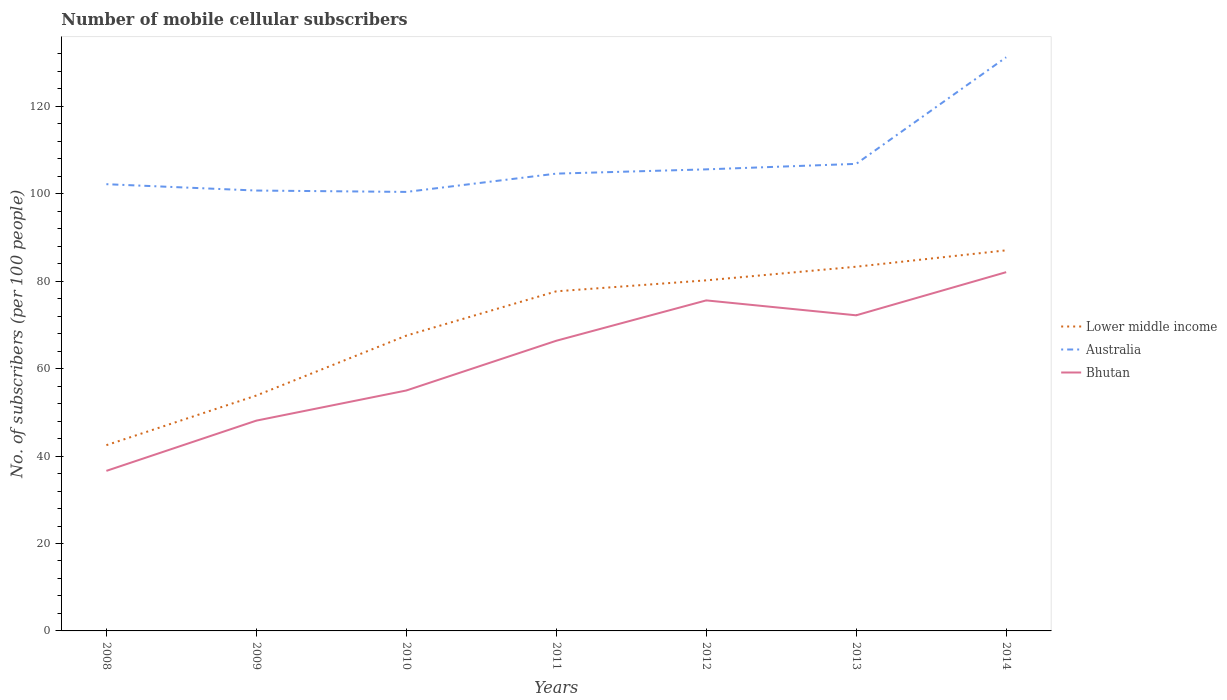How many different coloured lines are there?
Your answer should be compact. 3. Across all years, what is the maximum number of mobile cellular subscribers in Australia?
Offer a terse response. 100.43. What is the total number of mobile cellular subscribers in Australia in the graph?
Your response must be concise. -6.1. What is the difference between the highest and the second highest number of mobile cellular subscribers in Bhutan?
Ensure brevity in your answer.  45.46. Is the number of mobile cellular subscribers in Lower middle income strictly greater than the number of mobile cellular subscribers in Bhutan over the years?
Your response must be concise. No. What is the difference between two consecutive major ticks on the Y-axis?
Ensure brevity in your answer.  20. Does the graph contain grids?
Offer a very short reply. No. How many legend labels are there?
Provide a succinct answer. 3. What is the title of the graph?
Offer a terse response. Number of mobile cellular subscribers. Does "Sierra Leone" appear as one of the legend labels in the graph?
Offer a very short reply. No. What is the label or title of the Y-axis?
Give a very brief answer. No. of subscribers (per 100 people). What is the No. of subscribers (per 100 people) of Lower middle income in 2008?
Your answer should be compact. 42.49. What is the No. of subscribers (per 100 people) in Australia in 2008?
Provide a short and direct response. 102.19. What is the No. of subscribers (per 100 people) of Bhutan in 2008?
Ensure brevity in your answer.  36.61. What is the No. of subscribers (per 100 people) in Lower middle income in 2009?
Your answer should be very brief. 53.85. What is the No. of subscribers (per 100 people) in Australia in 2009?
Offer a very short reply. 100.74. What is the No. of subscribers (per 100 people) of Bhutan in 2009?
Your response must be concise. 48.11. What is the No. of subscribers (per 100 people) in Lower middle income in 2010?
Your answer should be very brief. 67.55. What is the No. of subscribers (per 100 people) of Australia in 2010?
Give a very brief answer. 100.43. What is the No. of subscribers (per 100 people) in Bhutan in 2010?
Your answer should be compact. 55. What is the No. of subscribers (per 100 people) of Lower middle income in 2011?
Give a very brief answer. 77.69. What is the No. of subscribers (per 100 people) in Australia in 2011?
Give a very brief answer. 104.61. What is the No. of subscribers (per 100 people) in Bhutan in 2011?
Provide a short and direct response. 66.38. What is the No. of subscribers (per 100 people) in Lower middle income in 2012?
Offer a very short reply. 80.2. What is the No. of subscribers (per 100 people) of Australia in 2012?
Provide a short and direct response. 105.59. What is the No. of subscribers (per 100 people) of Bhutan in 2012?
Provide a succinct answer. 75.61. What is the No. of subscribers (per 100 people) in Lower middle income in 2013?
Your response must be concise. 83.32. What is the No. of subscribers (per 100 people) in Australia in 2013?
Provide a succinct answer. 106.84. What is the No. of subscribers (per 100 people) of Bhutan in 2013?
Offer a very short reply. 72.2. What is the No. of subscribers (per 100 people) of Lower middle income in 2014?
Offer a terse response. 87.06. What is the No. of subscribers (per 100 people) in Australia in 2014?
Offer a terse response. 131.23. What is the No. of subscribers (per 100 people) of Bhutan in 2014?
Provide a succinct answer. 82.07. Across all years, what is the maximum No. of subscribers (per 100 people) of Lower middle income?
Keep it short and to the point. 87.06. Across all years, what is the maximum No. of subscribers (per 100 people) of Australia?
Your response must be concise. 131.23. Across all years, what is the maximum No. of subscribers (per 100 people) of Bhutan?
Your answer should be very brief. 82.07. Across all years, what is the minimum No. of subscribers (per 100 people) of Lower middle income?
Your answer should be very brief. 42.49. Across all years, what is the minimum No. of subscribers (per 100 people) in Australia?
Offer a terse response. 100.43. Across all years, what is the minimum No. of subscribers (per 100 people) of Bhutan?
Ensure brevity in your answer.  36.61. What is the total No. of subscribers (per 100 people) of Lower middle income in the graph?
Ensure brevity in your answer.  492.15. What is the total No. of subscribers (per 100 people) of Australia in the graph?
Your answer should be compact. 751.63. What is the total No. of subscribers (per 100 people) of Bhutan in the graph?
Keep it short and to the point. 435.98. What is the difference between the No. of subscribers (per 100 people) in Lower middle income in 2008 and that in 2009?
Your answer should be very brief. -11.36. What is the difference between the No. of subscribers (per 100 people) in Australia in 2008 and that in 2009?
Ensure brevity in your answer.  1.46. What is the difference between the No. of subscribers (per 100 people) in Bhutan in 2008 and that in 2009?
Offer a terse response. -11.49. What is the difference between the No. of subscribers (per 100 people) of Lower middle income in 2008 and that in 2010?
Make the answer very short. -25.06. What is the difference between the No. of subscribers (per 100 people) of Australia in 2008 and that in 2010?
Give a very brief answer. 1.77. What is the difference between the No. of subscribers (per 100 people) in Bhutan in 2008 and that in 2010?
Offer a terse response. -18.39. What is the difference between the No. of subscribers (per 100 people) of Lower middle income in 2008 and that in 2011?
Offer a very short reply. -35.19. What is the difference between the No. of subscribers (per 100 people) of Australia in 2008 and that in 2011?
Your answer should be very brief. -2.42. What is the difference between the No. of subscribers (per 100 people) of Bhutan in 2008 and that in 2011?
Ensure brevity in your answer.  -29.76. What is the difference between the No. of subscribers (per 100 people) in Lower middle income in 2008 and that in 2012?
Offer a terse response. -37.7. What is the difference between the No. of subscribers (per 100 people) in Australia in 2008 and that in 2012?
Offer a very short reply. -3.39. What is the difference between the No. of subscribers (per 100 people) in Bhutan in 2008 and that in 2012?
Ensure brevity in your answer.  -39. What is the difference between the No. of subscribers (per 100 people) of Lower middle income in 2008 and that in 2013?
Your answer should be very brief. -40.82. What is the difference between the No. of subscribers (per 100 people) of Australia in 2008 and that in 2013?
Keep it short and to the point. -4.65. What is the difference between the No. of subscribers (per 100 people) in Bhutan in 2008 and that in 2013?
Offer a terse response. -35.58. What is the difference between the No. of subscribers (per 100 people) of Lower middle income in 2008 and that in 2014?
Make the answer very short. -44.57. What is the difference between the No. of subscribers (per 100 people) of Australia in 2008 and that in 2014?
Your answer should be compact. -29.04. What is the difference between the No. of subscribers (per 100 people) of Bhutan in 2008 and that in 2014?
Provide a succinct answer. -45.46. What is the difference between the No. of subscribers (per 100 people) in Lower middle income in 2009 and that in 2010?
Your answer should be very brief. -13.7. What is the difference between the No. of subscribers (per 100 people) of Australia in 2009 and that in 2010?
Offer a terse response. 0.31. What is the difference between the No. of subscribers (per 100 people) of Bhutan in 2009 and that in 2010?
Your answer should be compact. -6.89. What is the difference between the No. of subscribers (per 100 people) in Lower middle income in 2009 and that in 2011?
Make the answer very short. -23.84. What is the difference between the No. of subscribers (per 100 people) of Australia in 2009 and that in 2011?
Make the answer very short. -3.87. What is the difference between the No. of subscribers (per 100 people) in Bhutan in 2009 and that in 2011?
Ensure brevity in your answer.  -18.27. What is the difference between the No. of subscribers (per 100 people) in Lower middle income in 2009 and that in 2012?
Ensure brevity in your answer.  -26.35. What is the difference between the No. of subscribers (per 100 people) in Australia in 2009 and that in 2012?
Your response must be concise. -4.85. What is the difference between the No. of subscribers (per 100 people) in Bhutan in 2009 and that in 2012?
Offer a very short reply. -27.5. What is the difference between the No. of subscribers (per 100 people) of Lower middle income in 2009 and that in 2013?
Provide a succinct answer. -29.47. What is the difference between the No. of subscribers (per 100 people) of Australia in 2009 and that in 2013?
Your answer should be very brief. -6.1. What is the difference between the No. of subscribers (per 100 people) of Bhutan in 2009 and that in 2013?
Your answer should be very brief. -24.09. What is the difference between the No. of subscribers (per 100 people) of Lower middle income in 2009 and that in 2014?
Keep it short and to the point. -33.22. What is the difference between the No. of subscribers (per 100 people) in Australia in 2009 and that in 2014?
Offer a terse response. -30.49. What is the difference between the No. of subscribers (per 100 people) in Bhutan in 2009 and that in 2014?
Offer a very short reply. -33.96. What is the difference between the No. of subscribers (per 100 people) of Lower middle income in 2010 and that in 2011?
Your response must be concise. -10.14. What is the difference between the No. of subscribers (per 100 people) of Australia in 2010 and that in 2011?
Give a very brief answer. -4.18. What is the difference between the No. of subscribers (per 100 people) of Bhutan in 2010 and that in 2011?
Offer a very short reply. -11.38. What is the difference between the No. of subscribers (per 100 people) in Lower middle income in 2010 and that in 2012?
Your response must be concise. -12.65. What is the difference between the No. of subscribers (per 100 people) of Australia in 2010 and that in 2012?
Keep it short and to the point. -5.16. What is the difference between the No. of subscribers (per 100 people) in Bhutan in 2010 and that in 2012?
Give a very brief answer. -20.61. What is the difference between the No. of subscribers (per 100 people) of Lower middle income in 2010 and that in 2013?
Offer a terse response. -15.77. What is the difference between the No. of subscribers (per 100 people) of Australia in 2010 and that in 2013?
Make the answer very short. -6.42. What is the difference between the No. of subscribers (per 100 people) in Bhutan in 2010 and that in 2013?
Your answer should be very brief. -17.2. What is the difference between the No. of subscribers (per 100 people) in Lower middle income in 2010 and that in 2014?
Offer a terse response. -19.51. What is the difference between the No. of subscribers (per 100 people) of Australia in 2010 and that in 2014?
Your answer should be compact. -30.8. What is the difference between the No. of subscribers (per 100 people) of Bhutan in 2010 and that in 2014?
Provide a succinct answer. -27.07. What is the difference between the No. of subscribers (per 100 people) of Lower middle income in 2011 and that in 2012?
Offer a very short reply. -2.51. What is the difference between the No. of subscribers (per 100 people) in Australia in 2011 and that in 2012?
Ensure brevity in your answer.  -0.98. What is the difference between the No. of subscribers (per 100 people) of Bhutan in 2011 and that in 2012?
Provide a succinct answer. -9.23. What is the difference between the No. of subscribers (per 100 people) in Lower middle income in 2011 and that in 2013?
Your response must be concise. -5.63. What is the difference between the No. of subscribers (per 100 people) in Australia in 2011 and that in 2013?
Your answer should be very brief. -2.23. What is the difference between the No. of subscribers (per 100 people) in Bhutan in 2011 and that in 2013?
Offer a very short reply. -5.82. What is the difference between the No. of subscribers (per 100 people) of Lower middle income in 2011 and that in 2014?
Keep it short and to the point. -9.38. What is the difference between the No. of subscribers (per 100 people) of Australia in 2011 and that in 2014?
Ensure brevity in your answer.  -26.62. What is the difference between the No. of subscribers (per 100 people) of Bhutan in 2011 and that in 2014?
Ensure brevity in your answer.  -15.69. What is the difference between the No. of subscribers (per 100 people) of Lower middle income in 2012 and that in 2013?
Your answer should be very brief. -3.12. What is the difference between the No. of subscribers (per 100 people) in Australia in 2012 and that in 2013?
Offer a very short reply. -1.26. What is the difference between the No. of subscribers (per 100 people) of Bhutan in 2012 and that in 2013?
Give a very brief answer. 3.41. What is the difference between the No. of subscribers (per 100 people) of Lower middle income in 2012 and that in 2014?
Offer a terse response. -6.87. What is the difference between the No. of subscribers (per 100 people) in Australia in 2012 and that in 2014?
Your answer should be very brief. -25.64. What is the difference between the No. of subscribers (per 100 people) in Bhutan in 2012 and that in 2014?
Your answer should be very brief. -6.46. What is the difference between the No. of subscribers (per 100 people) of Lower middle income in 2013 and that in 2014?
Your response must be concise. -3.75. What is the difference between the No. of subscribers (per 100 people) of Australia in 2013 and that in 2014?
Provide a succinct answer. -24.39. What is the difference between the No. of subscribers (per 100 people) of Bhutan in 2013 and that in 2014?
Keep it short and to the point. -9.87. What is the difference between the No. of subscribers (per 100 people) of Lower middle income in 2008 and the No. of subscribers (per 100 people) of Australia in 2009?
Keep it short and to the point. -58.25. What is the difference between the No. of subscribers (per 100 people) of Lower middle income in 2008 and the No. of subscribers (per 100 people) of Bhutan in 2009?
Your response must be concise. -5.62. What is the difference between the No. of subscribers (per 100 people) of Australia in 2008 and the No. of subscribers (per 100 people) of Bhutan in 2009?
Make the answer very short. 54.09. What is the difference between the No. of subscribers (per 100 people) in Lower middle income in 2008 and the No. of subscribers (per 100 people) in Australia in 2010?
Keep it short and to the point. -57.93. What is the difference between the No. of subscribers (per 100 people) of Lower middle income in 2008 and the No. of subscribers (per 100 people) of Bhutan in 2010?
Give a very brief answer. -12.51. What is the difference between the No. of subscribers (per 100 people) in Australia in 2008 and the No. of subscribers (per 100 people) in Bhutan in 2010?
Your answer should be compact. 47.19. What is the difference between the No. of subscribers (per 100 people) of Lower middle income in 2008 and the No. of subscribers (per 100 people) of Australia in 2011?
Offer a terse response. -62.12. What is the difference between the No. of subscribers (per 100 people) of Lower middle income in 2008 and the No. of subscribers (per 100 people) of Bhutan in 2011?
Provide a short and direct response. -23.89. What is the difference between the No. of subscribers (per 100 people) of Australia in 2008 and the No. of subscribers (per 100 people) of Bhutan in 2011?
Provide a short and direct response. 35.81. What is the difference between the No. of subscribers (per 100 people) in Lower middle income in 2008 and the No. of subscribers (per 100 people) in Australia in 2012?
Offer a terse response. -63.09. What is the difference between the No. of subscribers (per 100 people) in Lower middle income in 2008 and the No. of subscribers (per 100 people) in Bhutan in 2012?
Provide a short and direct response. -33.12. What is the difference between the No. of subscribers (per 100 people) in Australia in 2008 and the No. of subscribers (per 100 people) in Bhutan in 2012?
Ensure brevity in your answer.  26.58. What is the difference between the No. of subscribers (per 100 people) in Lower middle income in 2008 and the No. of subscribers (per 100 people) in Australia in 2013?
Offer a very short reply. -64.35. What is the difference between the No. of subscribers (per 100 people) of Lower middle income in 2008 and the No. of subscribers (per 100 people) of Bhutan in 2013?
Give a very brief answer. -29.71. What is the difference between the No. of subscribers (per 100 people) in Australia in 2008 and the No. of subscribers (per 100 people) in Bhutan in 2013?
Your response must be concise. 30. What is the difference between the No. of subscribers (per 100 people) of Lower middle income in 2008 and the No. of subscribers (per 100 people) of Australia in 2014?
Give a very brief answer. -88.74. What is the difference between the No. of subscribers (per 100 people) in Lower middle income in 2008 and the No. of subscribers (per 100 people) in Bhutan in 2014?
Offer a very short reply. -39.58. What is the difference between the No. of subscribers (per 100 people) in Australia in 2008 and the No. of subscribers (per 100 people) in Bhutan in 2014?
Offer a very short reply. 20.12. What is the difference between the No. of subscribers (per 100 people) of Lower middle income in 2009 and the No. of subscribers (per 100 people) of Australia in 2010?
Give a very brief answer. -46.58. What is the difference between the No. of subscribers (per 100 people) of Lower middle income in 2009 and the No. of subscribers (per 100 people) of Bhutan in 2010?
Provide a short and direct response. -1.15. What is the difference between the No. of subscribers (per 100 people) in Australia in 2009 and the No. of subscribers (per 100 people) in Bhutan in 2010?
Offer a terse response. 45.74. What is the difference between the No. of subscribers (per 100 people) in Lower middle income in 2009 and the No. of subscribers (per 100 people) in Australia in 2011?
Your response must be concise. -50.76. What is the difference between the No. of subscribers (per 100 people) in Lower middle income in 2009 and the No. of subscribers (per 100 people) in Bhutan in 2011?
Your answer should be very brief. -12.53. What is the difference between the No. of subscribers (per 100 people) of Australia in 2009 and the No. of subscribers (per 100 people) of Bhutan in 2011?
Provide a succinct answer. 34.36. What is the difference between the No. of subscribers (per 100 people) of Lower middle income in 2009 and the No. of subscribers (per 100 people) of Australia in 2012?
Your answer should be compact. -51.74. What is the difference between the No. of subscribers (per 100 people) of Lower middle income in 2009 and the No. of subscribers (per 100 people) of Bhutan in 2012?
Your response must be concise. -21.76. What is the difference between the No. of subscribers (per 100 people) of Australia in 2009 and the No. of subscribers (per 100 people) of Bhutan in 2012?
Ensure brevity in your answer.  25.13. What is the difference between the No. of subscribers (per 100 people) in Lower middle income in 2009 and the No. of subscribers (per 100 people) in Australia in 2013?
Keep it short and to the point. -53. What is the difference between the No. of subscribers (per 100 people) of Lower middle income in 2009 and the No. of subscribers (per 100 people) of Bhutan in 2013?
Your answer should be very brief. -18.35. What is the difference between the No. of subscribers (per 100 people) of Australia in 2009 and the No. of subscribers (per 100 people) of Bhutan in 2013?
Your answer should be compact. 28.54. What is the difference between the No. of subscribers (per 100 people) in Lower middle income in 2009 and the No. of subscribers (per 100 people) in Australia in 2014?
Provide a short and direct response. -77.38. What is the difference between the No. of subscribers (per 100 people) in Lower middle income in 2009 and the No. of subscribers (per 100 people) in Bhutan in 2014?
Offer a very short reply. -28.22. What is the difference between the No. of subscribers (per 100 people) of Australia in 2009 and the No. of subscribers (per 100 people) of Bhutan in 2014?
Offer a terse response. 18.67. What is the difference between the No. of subscribers (per 100 people) of Lower middle income in 2010 and the No. of subscribers (per 100 people) of Australia in 2011?
Your answer should be compact. -37.06. What is the difference between the No. of subscribers (per 100 people) of Lower middle income in 2010 and the No. of subscribers (per 100 people) of Bhutan in 2011?
Keep it short and to the point. 1.17. What is the difference between the No. of subscribers (per 100 people) of Australia in 2010 and the No. of subscribers (per 100 people) of Bhutan in 2011?
Offer a terse response. 34.05. What is the difference between the No. of subscribers (per 100 people) of Lower middle income in 2010 and the No. of subscribers (per 100 people) of Australia in 2012?
Ensure brevity in your answer.  -38.03. What is the difference between the No. of subscribers (per 100 people) of Lower middle income in 2010 and the No. of subscribers (per 100 people) of Bhutan in 2012?
Your answer should be very brief. -8.06. What is the difference between the No. of subscribers (per 100 people) of Australia in 2010 and the No. of subscribers (per 100 people) of Bhutan in 2012?
Provide a succinct answer. 24.82. What is the difference between the No. of subscribers (per 100 people) in Lower middle income in 2010 and the No. of subscribers (per 100 people) in Australia in 2013?
Your answer should be compact. -39.29. What is the difference between the No. of subscribers (per 100 people) of Lower middle income in 2010 and the No. of subscribers (per 100 people) of Bhutan in 2013?
Offer a very short reply. -4.65. What is the difference between the No. of subscribers (per 100 people) in Australia in 2010 and the No. of subscribers (per 100 people) in Bhutan in 2013?
Provide a short and direct response. 28.23. What is the difference between the No. of subscribers (per 100 people) of Lower middle income in 2010 and the No. of subscribers (per 100 people) of Australia in 2014?
Offer a terse response. -63.68. What is the difference between the No. of subscribers (per 100 people) in Lower middle income in 2010 and the No. of subscribers (per 100 people) in Bhutan in 2014?
Ensure brevity in your answer.  -14.52. What is the difference between the No. of subscribers (per 100 people) of Australia in 2010 and the No. of subscribers (per 100 people) of Bhutan in 2014?
Your answer should be very brief. 18.36. What is the difference between the No. of subscribers (per 100 people) in Lower middle income in 2011 and the No. of subscribers (per 100 people) in Australia in 2012?
Your answer should be very brief. -27.9. What is the difference between the No. of subscribers (per 100 people) of Lower middle income in 2011 and the No. of subscribers (per 100 people) of Bhutan in 2012?
Offer a very short reply. 2.08. What is the difference between the No. of subscribers (per 100 people) in Australia in 2011 and the No. of subscribers (per 100 people) in Bhutan in 2012?
Give a very brief answer. 29. What is the difference between the No. of subscribers (per 100 people) in Lower middle income in 2011 and the No. of subscribers (per 100 people) in Australia in 2013?
Offer a terse response. -29.16. What is the difference between the No. of subscribers (per 100 people) in Lower middle income in 2011 and the No. of subscribers (per 100 people) in Bhutan in 2013?
Make the answer very short. 5.49. What is the difference between the No. of subscribers (per 100 people) of Australia in 2011 and the No. of subscribers (per 100 people) of Bhutan in 2013?
Provide a succinct answer. 32.41. What is the difference between the No. of subscribers (per 100 people) in Lower middle income in 2011 and the No. of subscribers (per 100 people) in Australia in 2014?
Offer a terse response. -53.54. What is the difference between the No. of subscribers (per 100 people) of Lower middle income in 2011 and the No. of subscribers (per 100 people) of Bhutan in 2014?
Ensure brevity in your answer.  -4.38. What is the difference between the No. of subscribers (per 100 people) in Australia in 2011 and the No. of subscribers (per 100 people) in Bhutan in 2014?
Provide a succinct answer. 22.54. What is the difference between the No. of subscribers (per 100 people) of Lower middle income in 2012 and the No. of subscribers (per 100 people) of Australia in 2013?
Keep it short and to the point. -26.65. What is the difference between the No. of subscribers (per 100 people) in Lower middle income in 2012 and the No. of subscribers (per 100 people) in Bhutan in 2013?
Make the answer very short. 8. What is the difference between the No. of subscribers (per 100 people) of Australia in 2012 and the No. of subscribers (per 100 people) of Bhutan in 2013?
Give a very brief answer. 33.39. What is the difference between the No. of subscribers (per 100 people) in Lower middle income in 2012 and the No. of subscribers (per 100 people) in Australia in 2014?
Your answer should be compact. -51.03. What is the difference between the No. of subscribers (per 100 people) in Lower middle income in 2012 and the No. of subscribers (per 100 people) in Bhutan in 2014?
Offer a very short reply. -1.87. What is the difference between the No. of subscribers (per 100 people) of Australia in 2012 and the No. of subscribers (per 100 people) of Bhutan in 2014?
Offer a very short reply. 23.52. What is the difference between the No. of subscribers (per 100 people) of Lower middle income in 2013 and the No. of subscribers (per 100 people) of Australia in 2014?
Provide a succinct answer. -47.91. What is the difference between the No. of subscribers (per 100 people) of Lower middle income in 2013 and the No. of subscribers (per 100 people) of Bhutan in 2014?
Offer a very short reply. 1.25. What is the difference between the No. of subscribers (per 100 people) in Australia in 2013 and the No. of subscribers (per 100 people) in Bhutan in 2014?
Your answer should be very brief. 24.77. What is the average No. of subscribers (per 100 people) in Lower middle income per year?
Offer a very short reply. 70.31. What is the average No. of subscribers (per 100 people) of Australia per year?
Your response must be concise. 107.38. What is the average No. of subscribers (per 100 people) of Bhutan per year?
Make the answer very short. 62.28. In the year 2008, what is the difference between the No. of subscribers (per 100 people) in Lower middle income and No. of subscribers (per 100 people) in Australia?
Your answer should be compact. -59.7. In the year 2008, what is the difference between the No. of subscribers (per 100 people) of Lower middle income and No. of subscribers (per 100 people) of Bhutan?
Give a very brief answer. 5.88. In the year 2008, what is the difference between the No. of subscribers (per 100 people) of Australia and No. of subscribers (per 100 people) of Bhutan?
Ensure brevity in your answer.  65.58. In the year 2009, what is the difference between the No. of subscribers (per 100 people) of Lower middle income and No. of subscribers (per 100 people) of Australia?
Ensure brevity in your answer.  -46.89. In the year 2009, what is the difference between the No. of subscribers (per 100 people) in Lower middle income and No. of subscribers (per 100 people) in Bhutan?
Your answer should be compact. 5.74. In the year 2009, what is the difference between the No. of subscribers (per 100 people) of Australia and No. of subscribers (per 100 people) of Bhutan?
Provide a succinct answer. 52.63. In the year 2010, what is the difference between the No. of subscribers (per 100 people) in Lower middle income and No. of subscribers (per 100 people) in Australia?
Provide a succinct answer. -32.88. In the year 2010, what is the difference between the No. of subscribers (per 100 people) in Lower middle income and No. of subscribers (per 100 people) in Bhutan?
Offer a terse response. 12.55. In the year 2010, what is the difference between the No. of subscribers (per 100 people) in Australia and No. of subscribers (per 100 people) in Bhutan?
Your answer should be very brief. 45.43. In the year 2011, what is the difference between the No. of subscribers (per 100 people) in Lower middle income and No. of subscribers (per 100 people) in Australia?
Give a very brief answer. -26.92. In the year 2011, what is the difference between the No. of subscribers (per 100 people) of Lower middle income and No. of subscribers (per 100 people) of Bhutan?
Provide a short and direct response. 11.31. In the year 2011, what is the difference between the No. of subscribers (per 100 people) of Australia and No. of subscribers (per 100 people) of Bhutan?
Your answer should be very brief. 38.23. In the year 2012, what is the difference between the No. of subscribers (per 100 people) of Lower middle income and No. of subscribers (per 100 people) of Australia?
Offer a very short reply. -25.39. In the year 2012, what is the difference between the No. of subscribers (per 100 people) of Lower middle income and No. of subscribers (per 100 people) of Bhutan?
Offer a very short reply. 4.59. In the year 2012, what is the difference between the No. of subscribers (per 100 people) in Australia and No. of subscribers (per 100 people) in Bhutan?
Your answer should be compact. 29.98. In the year 2013, what is the difference between the No. of subscribers (per 100 people) in Lower middle income and No. of subscribers (per 100 people) in Australia?
Your answer should be compact. -23.53. In the year 2013, what is the difference between the No. of subscribers (per 100 people) of Lower middle income and No. of subscribers (per 100 people) of Bhutan?
Your answer should be compact. 11.12. In the year 2013, what is the difference between the No. of subscribers (per 100 people) in Australia and No. of subscribers (per 100 people) in Bhutan?
Your response must be concise. 34.65. In the year 2014, what is the difference between the No. of subscribers (per 100 people) of Lower middle income and No. of subscribers (per 100 people) of Australia?
Ensure brevity in your answer.  -44.17. In the year 2014, what is the difference between the No. of subscribers (per 100 people) of Lower middle income and No. of subscribers (per 100 people) of Bhutan?
Make the answer very short. 4.99. In the year 2014, what is the difference between the No. of subscribers (per 100 people) in Australia and No. of subscribers (per 100 people) in Bhutan?
Offer a terse response. 49.16. What is the ratio of the No. of subscribers (per 100 people) of Lower middle income in 2008 to that in 2009?
Keep it short and to the point. 0.79. What is the ratio of the No. of subscribers (per 100 people) in Australia in 2008 to that in 2009?
Keep it short and to the point. 1.01. What is the ratio of the No. of subscribers (per 100 people) in Bhutan in 2008 to that in 2009?
Provide a short and direct response. 0.76. What is the ratio of the No. of subscribers (per 100 people) of Lower middle income in 2008 to that in 2010?
Your answer should be very brief. 0.63. What is the ratio of the No. of subscribers (per 100 people) of Australia in 2008 to that in 2010?
Your answer should be compact. 1.02. What is the ratio of the No. of subscribers (per 100 people) in Bhutan in 2008 to that in 2010?
Keep it short and to the point. 0.67. What is the ratio of the No. of subscribers (per 100 people) of Lower middle income in 2008 to that in 2011?
Offer a very short reply. 0.55. What is the ratio of the No. of subscribers (per 100 people) of Australia in 2008 to that in 2011?
Make the answer very short. 0.98. What is the ratio of the No. of subscribers (per 100 people) of Bhutan in 2008 to that in 2011?
Provide a short and direct response. 0.55. What is the ratio of the No. of subscribers (per 100 people) of Lower middle income in 2008 to that in 2012?
Offer a terse response. 0.53. What is the ratio of the No. of subscribers (per 100 people) in Australia in 2008 to that in 2012?
Your answer should be compact. 0.97. What is the ratio of the No. of subscribers (per 100 people) in Bhutan in 2008 to that in 2012?
Keep it short and to the point. 0.48. What is the ratio of the No. of subscribers (per 100 people) of Lower middle income in 2008 to that in 2013?
Your answer should be compact. 0.51. What is the ratio of the No. of subscribers (per 100 people) in Australia in 2008 to that in 2013?
Give a very brief answer. 0.96. What is the ratio of the No. of subscribers (per 100 people) of Bhutan in 2008 to that in 2013?
Provide a short and direct response. 0.51. What is the ratio of the No. of subscribers (per 100 people) in Lower middle income in 2008 to that in 2014?
Your response must be concise. 0.49. What is the ratio of the No. of subscribers (per 100 people) of Australia in 2008 to that in 2014?
Provide a succinct answer. 0.78. What is the ratio of the No. of subscribers (per 100 people) of Bhutan in 2008 to that in 2014?
Keep it short and to the point. 0.45. What is the ratio of the No. of subscribers (per 100 people) in Lower middle income in 2009 to that in 2010?
Your answer should be compact. 0.8. What is the ratio of the No. of subscribers (per 100 people) in Australia in 2009 to that in 2010?
Offer a terse response. 1. What is the ratio of the No. of subscribers (per 100 people) in Bhutan in 2009 to that in 2010?
Provide a short and direct response. 0.87. What is the ratio of the No. of subscribers (per 100 people) of Lower middle income in 2009 to that in 2011?
Offer a terse response. 0.69. What is the ratio of the No. of subscribers (per 100 people) in Bhutan in 2009 to that in 2011?
Your response must be concise. 0.72. What is the ratio of the No. of subscribers (per 100 people) of Lower middle income in 2009 to that in 2012?
Offer a very short reply. 0.67. What is the ratio of the No. of subscribers (per 100 people) of Australia in 2009 to that in 2012?
Provide a succinct answer. 0.95. What is the ratio of the No. of subscribers (per 100 people) in Bhutan in 2009 to that in 2012?
Offer a terse response. 0.64. What is the ratio of the No. of subscribers (per 100 people) in Lower middle income in 2009 to that in 2013?
Ensure brevity in your answer.  0.65. What is the ratio of the No. of subscribers (per 100 people) of Australia in 2009 to that in 2013?
Offer a terse response. 0.94. What is the ratio of the No. of subscribers (per 100 people) in Bhutan in 2009 to that in 2013?
Your answer should be very brief. 0.67. What is the ratio of the No. of subscribers (per 100 people) in Lower middle income in 2009 to that in 2014?
Keep it short and to the point. 0.62. What is the ratio of the No. of subscribers (per 100 people) in Australia in 2009 to that in 2014?
Offer a terse response. 0.77. What is the ratio of the No. of subscribers (per 100 people) in Bhutan in 2009 to that in 2014?
Provide a short and direct response. 0.59. What is the ratio of the No. of subscribers (per 100 people) of Lower middle income in 2010 to that in 2011?
Your answer should be very brief. 0.87. What is the ratio of the No. of subscribers (per 100 people) of Australia in 2010 to that in 2011?
Provide a short and direct response. 0.96. What is the ratio of the No. of subscribers (per 100 people) in Bhutan in 2010 to that in 2011?
Your answer should be very brief. 0.83. What is the ratio of the No. of subscribers (per 100 people) in Lower middle income in 2010 to that in 2012?
Your answer should be compact. 0.84. What is the ratio of the No. of subscribers (per 100 people) in Australia in 2010 to that in 2012?
Your answer should be very brief. 0.95. What is the ratio of the No. of subscribers (per 100 people) of Bhutan in 2010 to that in 2012?
Your response must be concise. 0.73. What is the ratio of the No. of subscribers (per 100 people) of Lower middle income in 2010 to that in 2013?
Offer a very short reply. 0.81. What is the ratio of the No. of subscribers (per 100 people) in Australia in 2010 to that in 2013?
Offer a terse response. 0.94. What is the ratio of the No. of subscribers (per 100 people) of Bhutan in 2010 to that in 2013?
Give a very brief answer. 0.76. What is the ratio of the No. of subscribers (per 100 people) of Lower middle income in 2010 to that in 2014?
Offer a terse response. 0.78. What is the ratio of the No. of subscribers (per 100 people) of Australia in 2010 to that in 2014?
Provide a succinct answer. 0.77. What is the ratio of the No. of subscribers (per 100 people) of Bhutan in 2010 to that in 2014?
Offer a terse response. 0.67. What is the ratio of the No. of subscribers (per 100 people) in Lower middle income in 2011 to that in 2012?
Your response must be concise. 0.97. What is the ratio of the No. of subscribers (per 100 people) in Australia in 2011 to that in 2012?
Offer a terse response. 0.99. What is the ratio of the No. of subscribers (per 100 people) in Bhutan in 2011 to that in 2012?
Your response must be concise. 0.88. What is the ratio of the No. of subscribers (per 100 people) of Lower middle income in 2011 to that in 2013?
Ensure brevity in your answer.  0.93. What is the ratio of the No. of subscribers (per 100 people) in Australia in 2011 to that in 2013?
Offer a very short reply. 0.98. What is the ratio of the No. of subscribers (per 100 people) of Bhutan in 2011 to that in 2013?
Your response must be concise. 0.92. What is the ratio of the No. of subscribers (per 100 people) of Lower middle income in 2011 to that in 2014?
Make the answer very short. 0.89. What is the ratio of the No. of subscribers (per 100 people) in Australia in 2011 to that in 2014?
Your answer should be compact. 0.8. What is the ratio of the No. of subscribers (per 100 people) in Bhutan in 2011 to that in 2014?
Provide a short and direct response. 0.81. What is the ratio of the No. of subscribers (per 100 people) of Lower middle income in 2012 to that in 2013?
Your answer should be very brief. 0.96. What is the ratio of the No. of subscribers (per 100 people) in Australia in 2012 to that in 2013?
Give a very brief answer. 0.99. What is the ratio of the No. of subscribers (per 100 people) in Bhutan in 2012 to that in 2013?
Offer a terse response. 1.05. What is the ratio of the No. of subscribers (per 100 people) of Lower middle income in 2012 to that in 2014?
Keep it short and to the point. 0.92. What is the ratio of the No. of subscribers (per 100 people) of Australia in 2012 to that in 2014?
Provide a short and direct response. 0.8. What is the ratio of the No. of subscribers (per 100 people) in Bhutan in 2012 to that in 2014?
Keep it short and to the point. 0.92. What is the ratio of the No. of subscribers (per 100 people) of Australia in 2013 to that in 2014?
Give a very brief answer. 0.81. What is the ratio of the No. of subscribers (per 100 people) in Bhutan in 2013 to that in 2014?
Ensure brevity in your answer.  0.88. What is the difference between the highest and the second highest No. of subscribers (per 100 people) of Lower middle income?
Offer a terse response. 3.75. What is the difference between the highest and the second highest No. of subscribers (per 100 people) of Australia?
Ensure brevity in your answer.  24.39. What is the difference between the highest and the second highest No. of subscribers (per 100 people) of Bhutan?
Make the answer very short. 6.46. What is the difference between the highest and the lowest No. of subscribers (per 100 people) of Lower middle income?
Your answer should be compact. 44.57. What is the difference between the highest and the lowest No. of subscribers (per 100 people) in Australia?
Make the answer very short. 30.8. What is the difference between the highest and the lowest No. of subscribers (per 100 people) in Bhutan?
Provide a short and direct response. 45.46. 